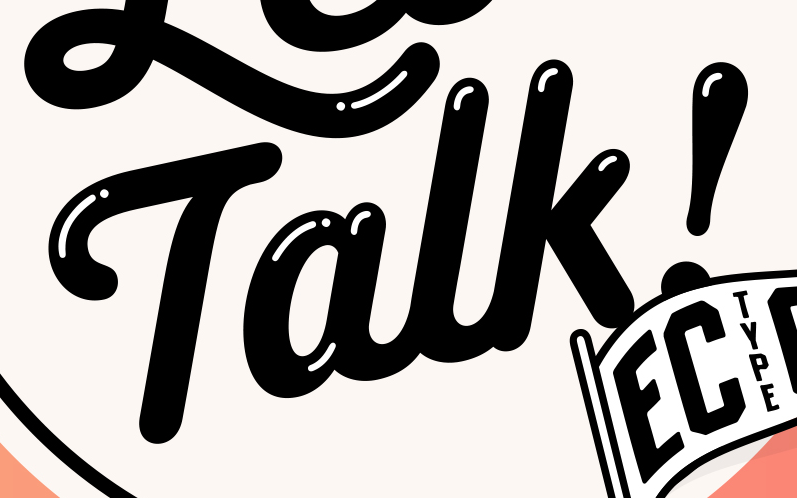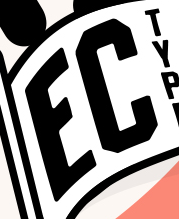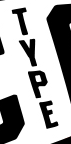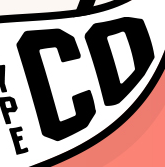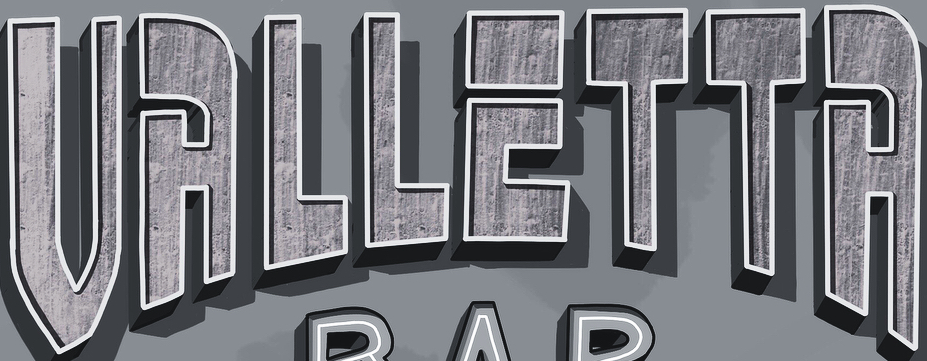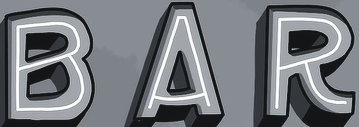Transcribe the words shown in these images in order, separated by a semicolon. Talk!; EC; TYPE; CD; VALLETTA; BAR 